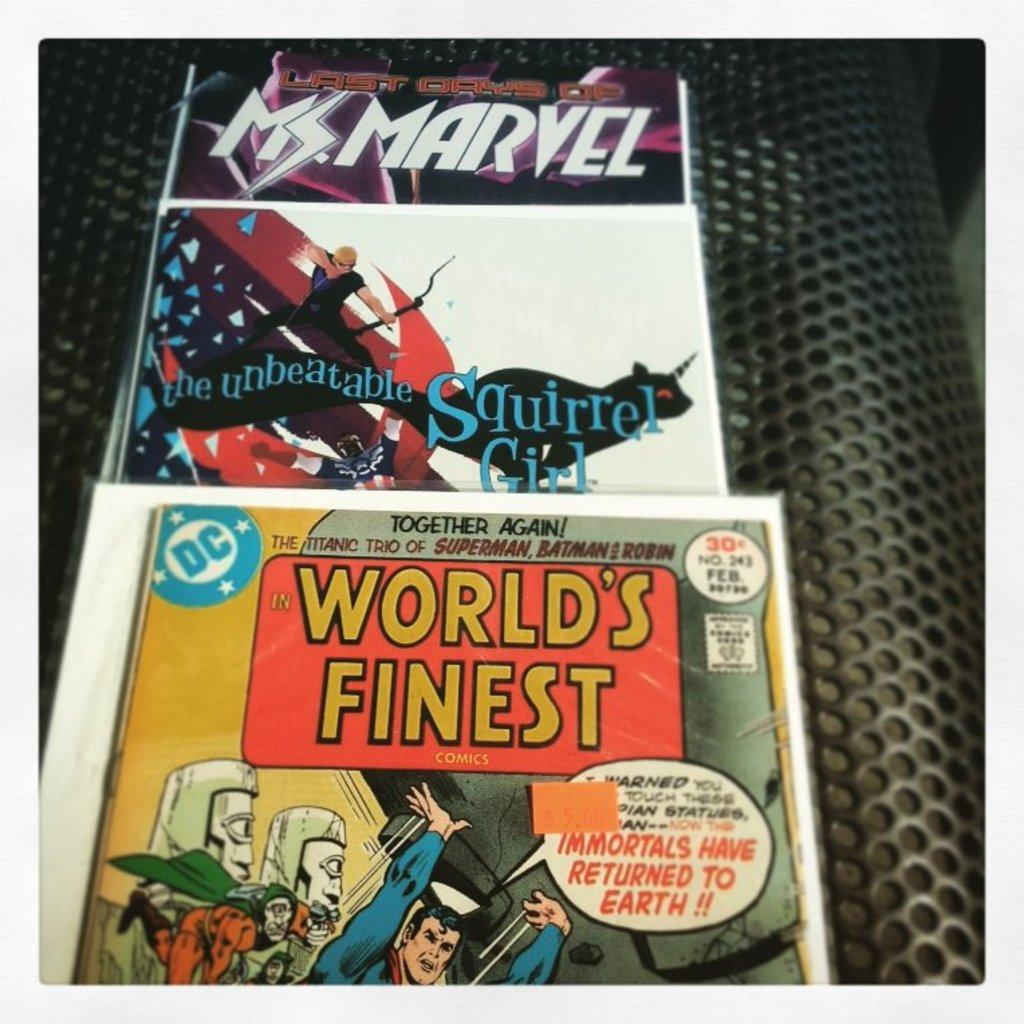<image>
Present a compact description of the photo's key features. A comic book titled "World's Finest" and "Ms. Marvel". 